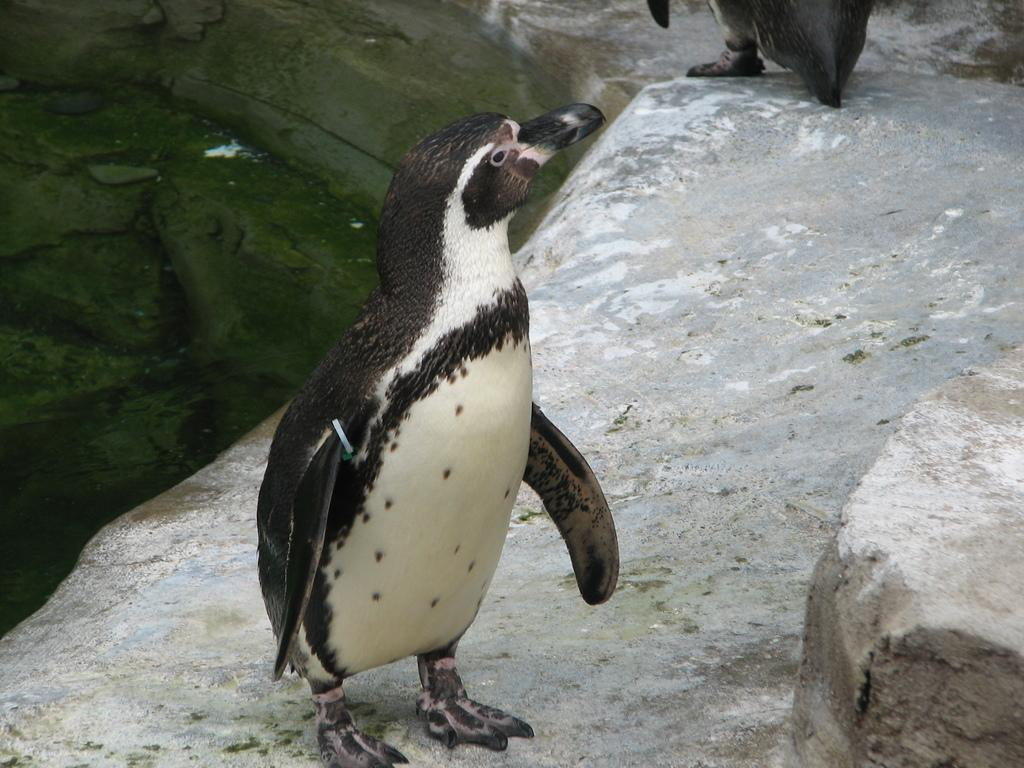What type of animals are in the image? There are penguins in the image. Where are the penguins located? The penguins are on a rock. What type of vessel is being used by the penguin expert in the image? There is no vessel or expert present in the image; it only features penguins on a rock. 